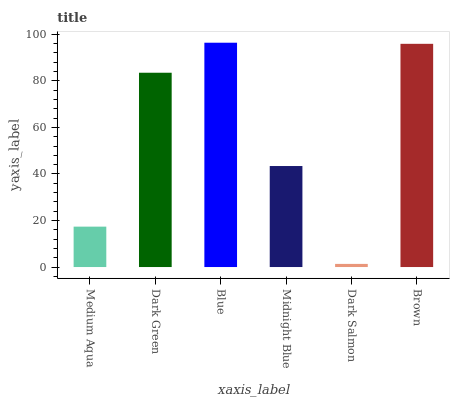Is Dark Salmon the minimum?
Answer yes or no. Yes. Is Blue the maximum?
Answer yes or no. Yes. Is Dark Green the minimum?
Answer yes or no. No. Is Dark Green the maximum?
Answer yes or no. No. Is Dark Green greater than Medium Aqua?
Answer yes or no. Yes. Is Medium Aqua less than Dark Green?
Answer yes or no. Yes. Is Medium Aqua greater than Dark Green?
Answer yes or no. No. Is Dark Green less than Medium Aqua?
Answer yes or no. No. Is Dark Green the high median?
Answer yes or no. Yes. Is Midnight Blue the low median?
Answer yes or no. Yes. Is Blue the high median?
Answer yes or no. No. Is Medium Aqua the low median?
Answer yes or no. No. 